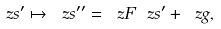Convert formula to latex. <formula><loc_0><loc_0><loc_500><loc_500>\ z s ^ { \prime } \mapsto \ z s ^ { \prime \prime } = \ z F \ z s ^ { \prime } + \ z g ,</formula> 